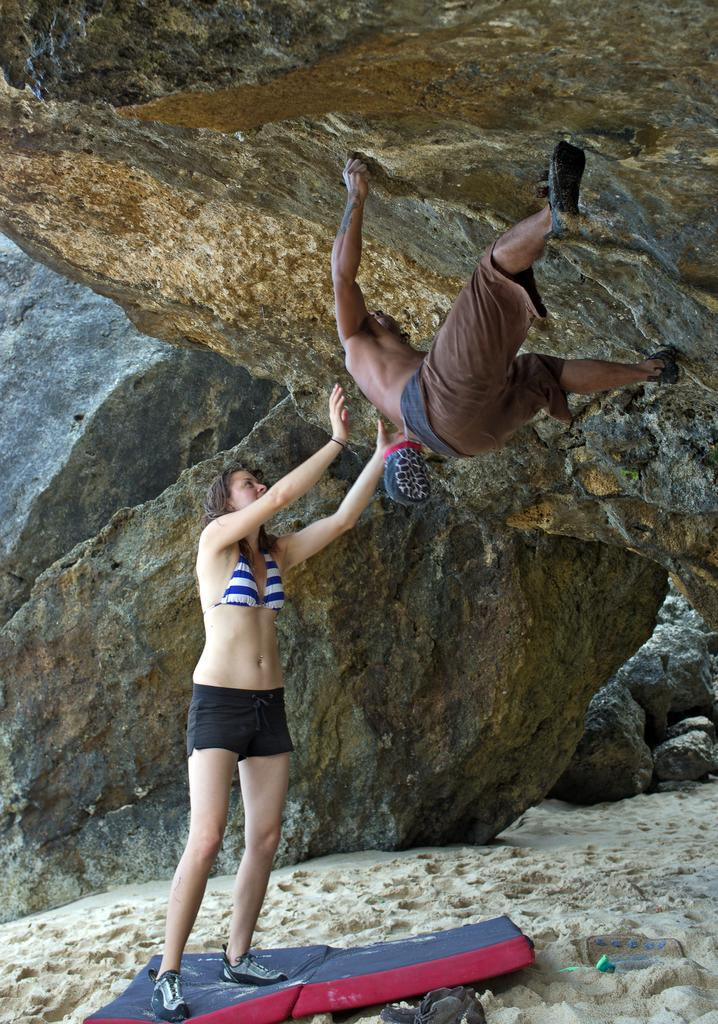What is the main subject of the image? There is a girl standing in the image. What can be seen in the background of the image? There are rocks at the top of the image. What is the man in the image doing? A man is climbing the rocks in the image. What type of street can be seen in the image? There is no street present in the image; it features a girl standing and a man climbing rocks. 